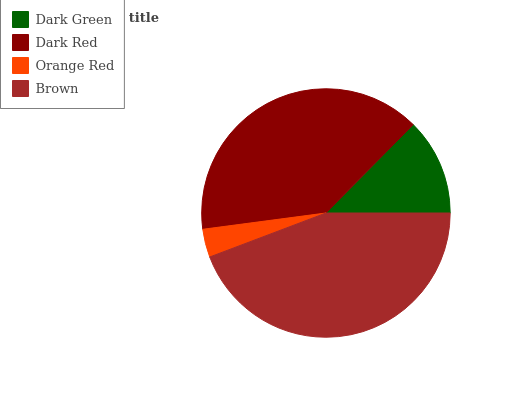Is Orange Red the minimum?
Answer yes or no. Yes. Is Brown the maximum?
Answer yes or no. Yes. Is Dark Red the minimum?
Answer yes or no. No. Is Dark Red the maximum?
Answer yes or no. No. Is Dark Red greater than Dark Green?
Answer yes or no. Yes. Is Dark Green less than Dark Red?
Answer yes or no. Yes. Is Dark Green greater than Dark Red?
Answer yes or no. No. Is Dark Red less than Dark Green?
Answer yes or no. No. Is Dark Red the high median?
Answer yes or no. Yes. Is Dark Green the low median?
Answer yes or no. Yes. Is Dark Green the high median?
Answer yes or no. No. Is Brown the low median?
Answer yes or no. No. 